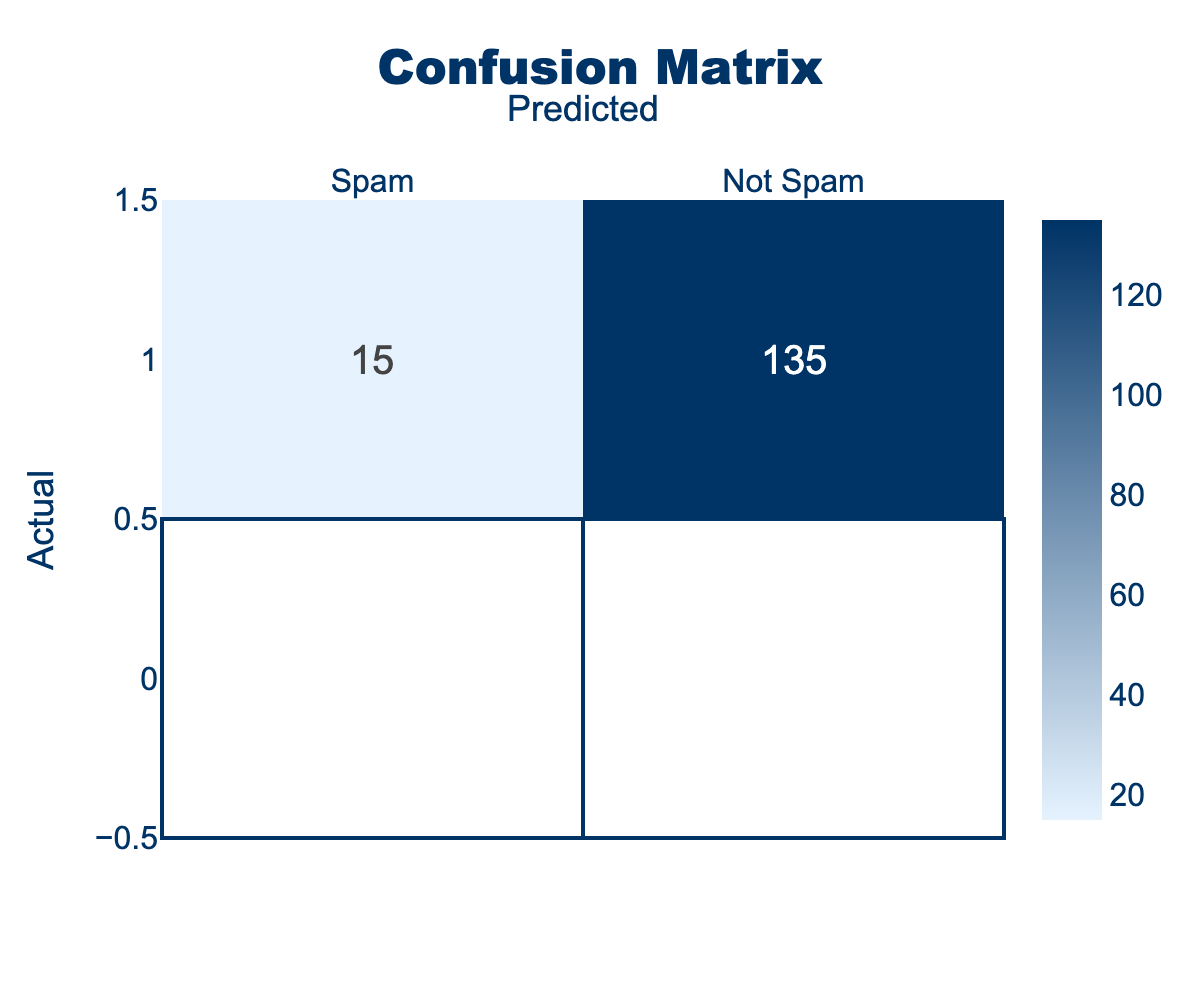What is the number of true positive predictions for spam? The true positive predictions for spam are represented as the value where both actual and predicted labels are "Spam." Referring to the table, the entry for "Spam" under "Spam" is 120.
Answer: 120 What is the number of false negatives? False negatives occur when the actual class is "Spam," but the model predicts "Not Spam." From the table, this value is found in the "Not Spam" column of the "Spam" row, which is 30.
Answer: 30 How many total instances were predicted to be “Not Spam”? To find the total instances predicted as “Not Spam,” we need to sum the values in the "Not Spam" column. From the table, this includes both “Not Spam” predicted as “Not Spam” (135) and “Spam” predicted as “Not Spam” (30). The total is 135 + 30 = 165.
Answer: 165 What is the accuracy of the model? Accuracy is calculated by the formula: (True Positives + True Negatives) / Total Instances. Here, true positives are 120 (Spam correctly predicted as Spam) and true negatives are 135 (Not Spam correctly predicted). The total instances are 120 + 30 + 15 + 135 = 300. Thus, accuracy = (120 + 135) / 300 = 255 / 300 = 0.85 or 85%.
Answer: 85% Are there more false positives or false negatives? False positives occur when the actual class is "Not Spam," but it is predicted as "Spam," which is 15. False negatives occur when "Spam" is predicted as "Not Spam," which is 30. Since 30 is greater than 15, there are more false negatives.
Answer: Yes What is the number of correct predictions? Correct predictions consist of true positives and true negatives. Adding the true positives (120) to the true negatives (135): 120 + 135 = 255.
Answer: 255 What percentage of actual Spam emails were correctly identified? The percentage of correctly identified Spam emails is determined by (True Positives / Total Actual Spam) * 100. Total actual Spam is true positives (120) plus false negatives (30), which equals 150. Therefore, the percentage is (120 / 150) * 100 = 80%.
Answer: 80% If the model predicts an email as Spam, what is the probability that it is truly Spam? This probability is known as precision and is calculated by the formula: True Positives / (True Positives + False Positives). Here, True Positives are 120, and False Positives are 15. Thus, precision = 120 / (120 + 15) = 120 / 135 = 0.888 or 88.8%.
Answer: 88.8% 